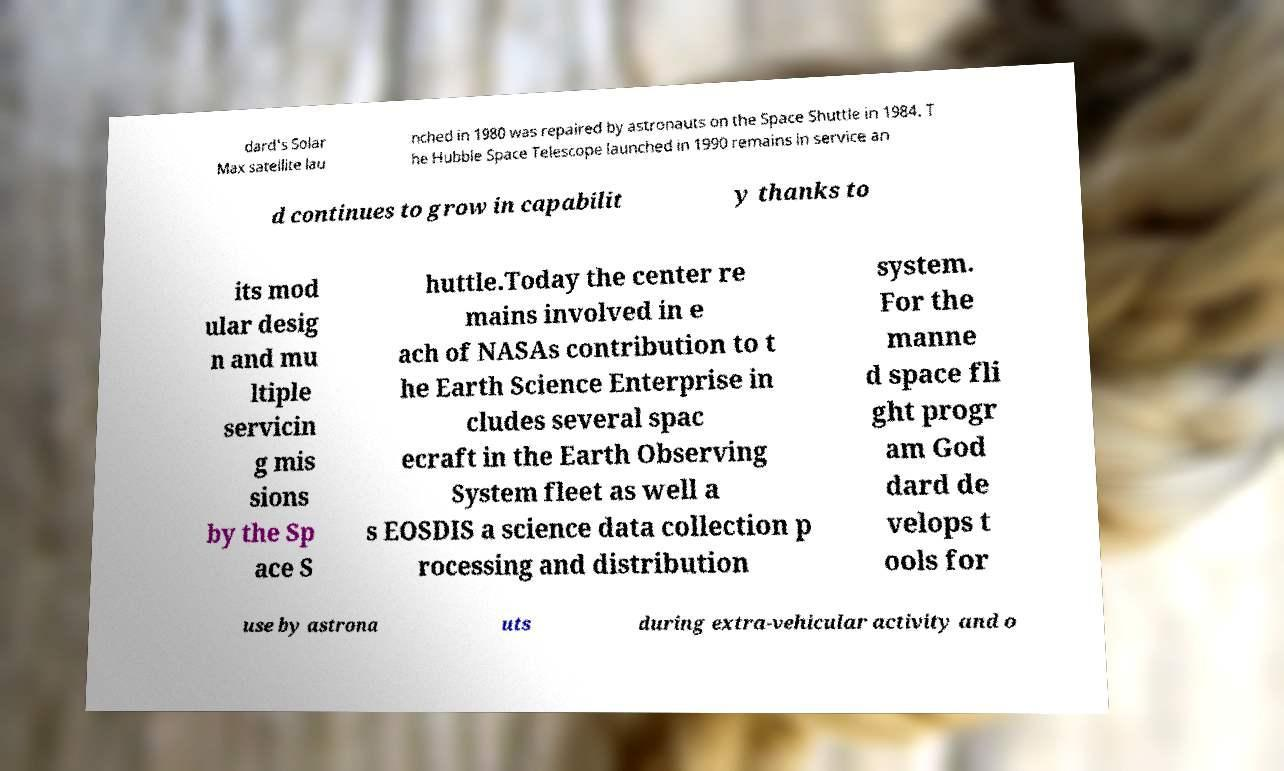Can you accurately transcribe the text from the provided image for me? dard's Solar Max satellite lau nched in 1980 was repaired by astronauts on the Space Shuttle in 1984. T he Hubble Space Telescope launched in 1990 remains in service an d continues to grow in capabilit y thanks to its mod ular desig n and mu ltiple servicin g mis sions by the Sp ace S huttle.Today the center re mains involved in e ach of NASAs contribution to t he Earth Science Enterprise in cludes several spac ecraft in the Earth Observing System fleet as well a s EOSDIS a science data collection p rocessing and distribution system. For the manne d space fli ght progr am God dard de velops t ools for use by astrona uts during extra-vehicular activity and o 